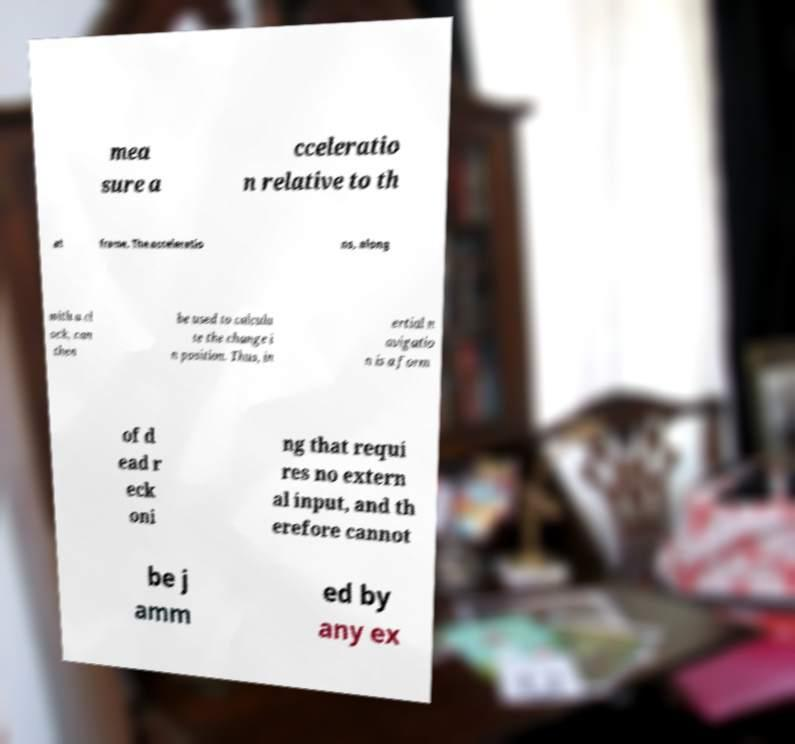There's text embedded in this image that I need extracted. Can you transcribe it verbatim? mea sure a cceleratio n relative to th at frame. The acceleratio ns, along with a cl ock, can then be used to calcula te the change i n position. Thus, in ertial n avigatio n is a form of d ead r eck oni ng that requi res no extern al input, and th erefore cannot be j amm ed by any ex 